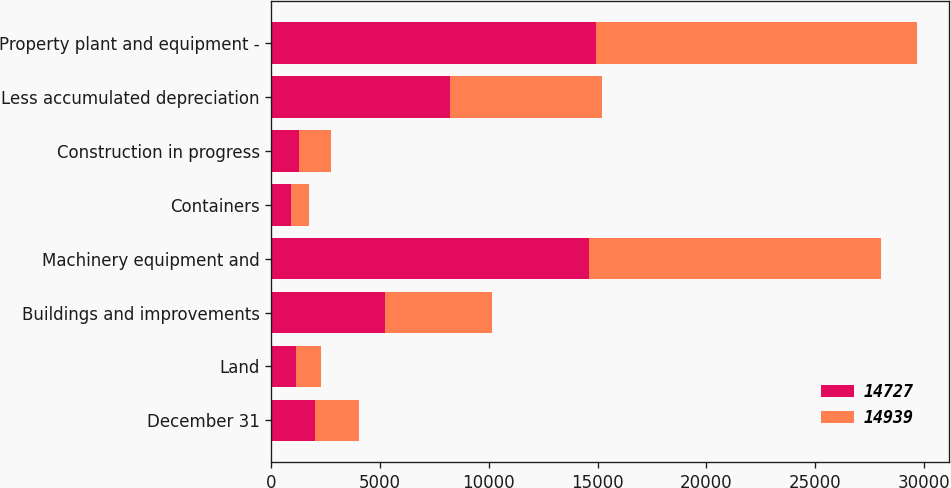<chart> <loc_0><loc_0><loc_500><loc_500><stacked_bar_chart><ecel><fcel>December 31<fcel>Land<fcel>Buildings and improvements<fcel>Machinery equipment and<fcel>Containers<fcel>Construction in progress<fcel>Less accumulated depreciation<fcel>Property plant and equipment -<nl><fcel>14727<fcel>2011<fcel>1141<fcel>5240<fcel>14609<fcel>895<fcel>1266<fcel>8212<fcel>14939<nl><fcel>14939<fcel>2010<fcel>1122<fcel>4883<fcel>13421<fcel>826<fcel>1454<fcel>6979<fcel>14727<nl></chart> 